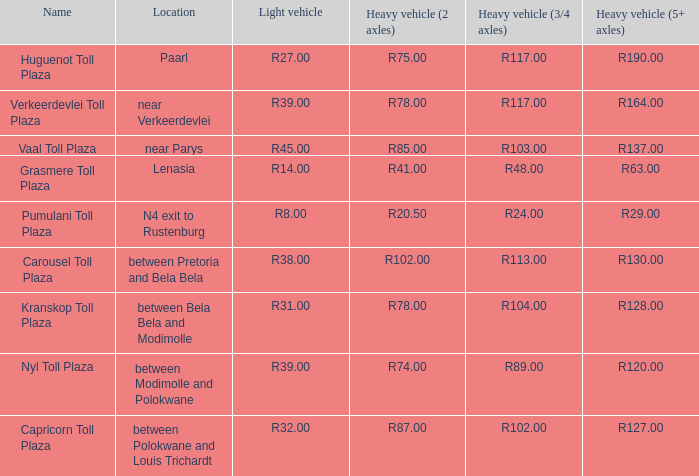What is the toll for heavy vehicles with 3/4 axles at Verkeerdevlei toll plaza? R117.00. 